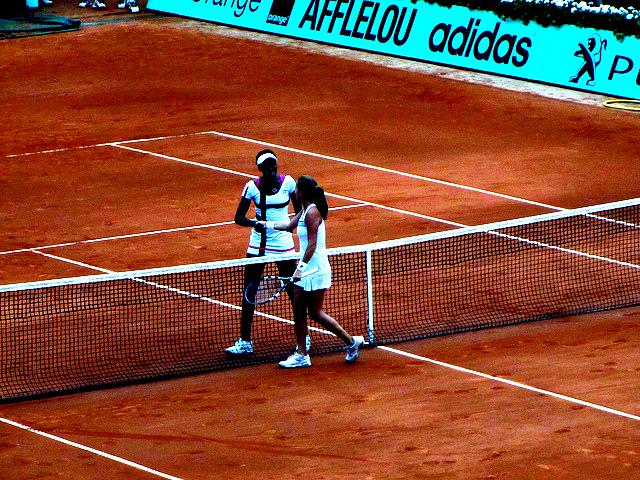Are there any quality issues with this image? Yes, there are a few quality issues. The image appears to have high noise levels, which could be due to low lighting or a high ISO setting. Additionally, the colors seem saturated, which might distort the true colors of the scene. The resolution is also not very high, making the details less crisp. 